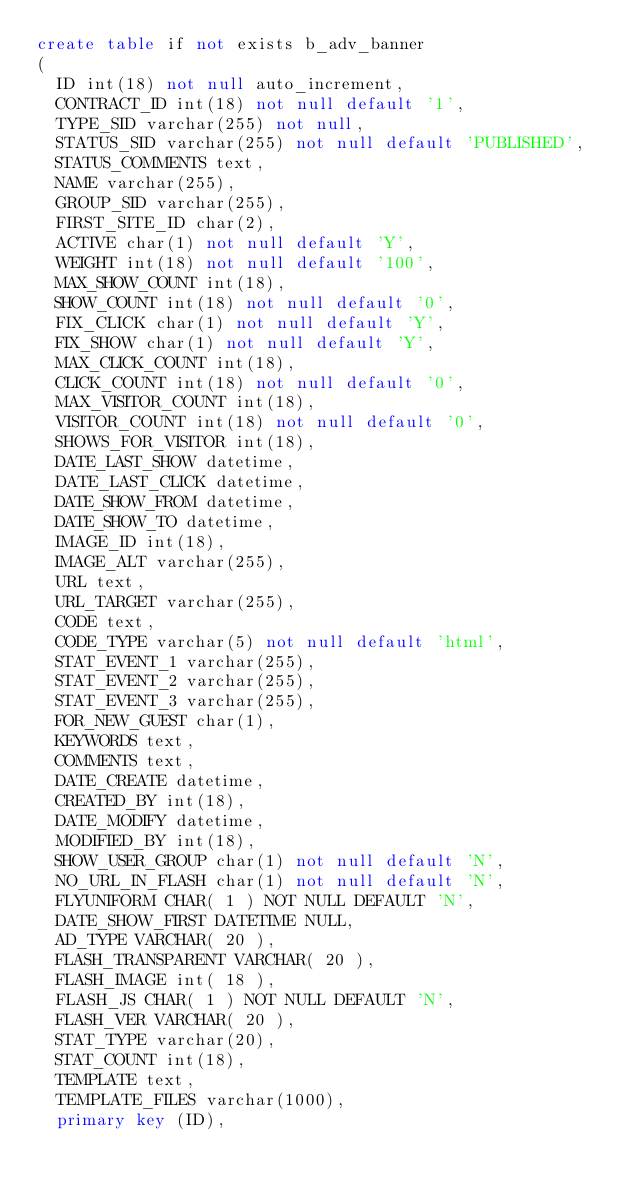<code> <loc_0><loc_0><loc_500><loc_500><_SQL_>create table if not exists b_adv_banner
(
	ID int(18) not null auto_increment,
	CONTRACT_ID int(18) not null default '1',
	TYPE_SID varchar(255) not null,
	STATUS_SID varchar(255) not null default 'PUBLISHED',
	STATUS_COMMENTS text,
	NAME varchar(255),
	GROUP_SID varchar(255),
	FIRST_SITE_ID char(2),
	ACTIVE char(1) not null default 'Y',
	WEIGHT int(18) not null default '100',
	MAX_SHOW_COUNT int(18),
	SHOW_COUNT int(18) not null default '0',
	FIX_CLICK char(1) not null default 'Y',
	FIX_SHOW char(1) not null default 'Y',
	MAX_CLICK_COUNT int(18),
	CLICK_COUNT int(18) not null default '0',
	MAX_VISITOR_COUNT int(18),
	VISITOR_COUNT int(18) not null default '0',
	SHOWS_FOR_VISITOR int(18),
	DATE_LAST_SHOW datetime,
	DATE_LAST_CLICK datetime,
	DATE_SHOW_FROM datetime,
	DATE_SHOW_TO datetime,
	IMAGE_ID int(18),
	IMAGE_ALT varchar(255),
	URL text,
	URL_TARGET varchar(255),
	CODE text,
	CODE_TYPE varchar(5) not null default 'html',
	STAT_EVENT_1 varchar(255),
	STAT_EVENT_2 varchar(255),
	STAT_EVENT_3 varchar(255),
	FOR_NEW_GUEST char(1),
	KEYWORDS text,
	COMMENTS text,
	DATE_CREATE datetime,
	CREATED_BY int(18),
	DATE_MODIFY datetime,
	MODIFIED_BY int(18),
	SHOW_USER_GROUP char(1) not null default 'N',
	NO_URL_IN_FLASH char(1) not null default 'N',
	FLYUNIFORM CHAR( 1 ) NOT NULL DEFAULT 'N',
	DATE_SHOW_FIRST DATETIME NULL,
	AD_TYPE VARCHAR( 20 ),
	FLASH_TRANSPARENT VARCHAR( 20 ),
	FLASH_IMAGE int( 18 ),
	FLASH_JS CHAR( 1 ) NOT NULL DEFAULT 'N',
	FLASH_VER VARCHAR( 20 ),
	STAT_TYPE varchar(20),
	STAT_COUNT int(18),
	TEMPLATE text,
	TEMPLATE_FILES varchar(1000),
	primary key (ID),</code> 